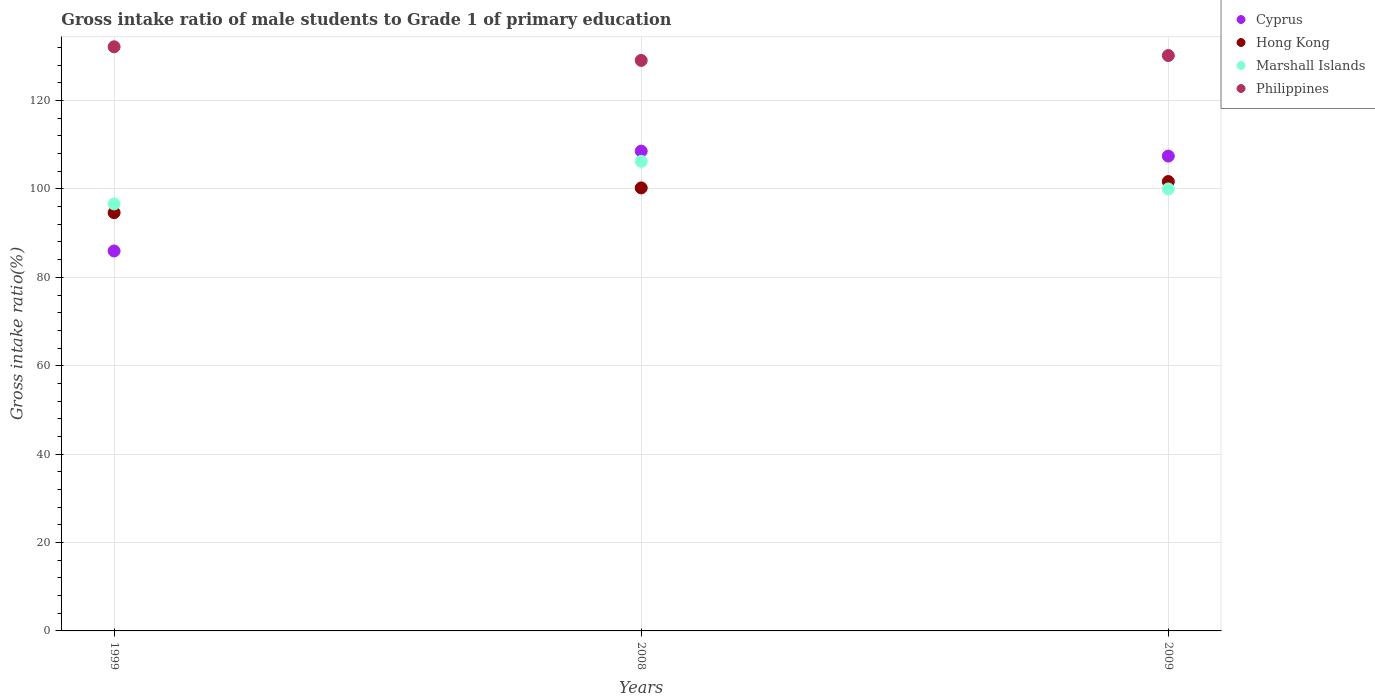How many different coloured dotlines are there?
Keep it short and to the point. 4. What is the gross intake ratio in Marshall Islands in 2009?
Offer a very short reply. 100. Across all years, what is the maximum gross intake ratio in Marshall Islands?
Provide a succinct answer. 106.25. Across all years, what is the minimum gross intake ratio in Cyprus?
Your answer should be compact. 85.97. In which year was the gross intake ratio in Hong Kong maximum?
Give a very brief answer. 2009. In which year was the gross intake ratio in Philippines minimum?
Ensure brevity in your answer.  2008. What is the total gross intake ratio in Philippines in the graph?
Offer a terse response. 391.44. What is the difference between the gross intake ratio in Philippines in 1999 and that in 2008?
Your response must be concise. 3.08. What is the difference between the gross intake ratio in Hong Kong in 1999 and the gross intake ratio in Philippines in 2008?
Your answer should be very brief. -34.45. What is the average gross intake ratio in Cyprus per year?
Give a very brief answer. 100.66. In the year 2009, what is the difference between the gross intake ratio in Hong Kong and gross intake ratio in Cyprus?
Ensure brevity in your answer.  -5.76. In how many years, is the gross intake ratio in Philippines greater than 36 %?
Ensure brevity in your answer.  3. What is the ratio of the gross intake ratio in Philippines in 1999 to that in 2008?
Make the answer very short. 1.02. Is the gross intake ratio in Philippines in 1999 less than that in 2008?
Give a very brief answer. No. What is the difference between the highest and the second highest gross intake ratio in Marshall Islands?
Keep it short and to the point. 6.25. What is the difference between the highest and the lowest gross intake ratio in Hong Kong?
Provide a succinct answer. 7.04. Is it the case that in every year, the sum of the gross intake ratio in Marshall Islands and gross intake ratio in Hong Kong  is greater than the sum of gross intake ratio in Philippines and gross intake ratio in Cyprus?
Your response must be concise. No. Does the gross intake ratio in Marshall Islands monotonically increase over the years?
Your answer should be very brief. No. Is the gross intake ratio in Marshall Islands strictly greater than the gross intake ratio in Hong Kong over the years?
Offer a very short reply. No. Is the gross intake ratio in Marshall Islands strictly less than the gross intake ratio in Hong Kong over the years?
Provide a succinct answer. No. What is the difference between two consecutive major ticks on the Y-axis?
Offer a terse response. 20. Does the graph contain any zero values?
Your answer should be compact. No. How many legend labels are there?
Provide a short and direct response. 4. What is the title of the graph?
Your response must be concise. Gross intake ratio of male students to Grade 1 of primary education. What is the label or title of the X-axis?
Your answer should be very brief. Years. What is the label or title of the Y-axis?
Keep it short and to the point. Gross intake ratio(%). What is the Gross intake ratio(%) of Cyprus in 1999?
Your response must be concise. 85.97. What is the Gross intake ratio(%) of Hong Kong in 1999?
Your response must be concise. 94.64. What is the Gross intake ratio(%) of Marshall Islands in 1999?
Offer a very short reply. 96.61. What is the Gross intake ratio(%) in Philippines in 1999?
Offer a very short reply. 132.17. What is the Gross intake ratio(%) of Cyprus in 2008?
Your answer should be compact. 108.57. What is the Gross intake ratio(%) of Hong Kong in 2008?
Your answer should be very brief. 100.24. What is the Gross intake ratio(%) in Marshall Islands in 2008?
Make the answer very short. 106.25. What is the Gross intake ratio(%) in Philippines in 2008?
Your answer should be very brief. 129.09. What is the Gross intake ratio(%) of Cyprus in 2009?
Your answer should be compact. 107.44. What is the Gross intake ratio(%) of Hong Kong in 2009?
Offer a terse response. 101.68. What is the Gross intake ratio(%) of Philippines in 2009?
Your response must be concise. 130.19. Across all years, what is the maximum Gross intake ratio(%) in Cyprus?
Your response must be concise. 108.57. Across all years, what is the maximum Gross intake ratio(%) in Hong Kong?
Provide a succinct answer. 101.68. Across all years, what is the maximum Gross intake ratio(%) of Marshall Islands?
Make the answer very short. 106.25. Across all years, what is the maximum Gross intake ratio(%) of Philippines?
Offer a very short reply. 132.17. Across all years, what is the minimum Gross intake ratio(%) in Cyprus?
Make the answer very short. 85.97. Across all years, what is the minimum Gross intake ratio(%) of Hong Kong?
Ensure brevity in your answer.  94.64. Across all years, what is the minimum Gross intake ratio(%) in Marshall Islands?
Your answer should be very brief. 96.61. Across all years, what is the minimum Gross intake ratio(%) of Philippines?
Make the answer very short. 129.09. What is the total Gross intake ratio(%) of Cyprus in the graph?
Your answer should be very brief. 301.97. What is the total Gross intake ratio(%) of Hong Kong in the graph?
Your answer should be compact. 296.55. What is the total Gross intake ratio(%) in Marshall Islands in the graph?
Give a very brief answer. 302.86. What is the total Gross intake ratio(%) of Philippines in the graph?
Offer a terse response. 391.44. What is the difference between the Gross intake ratio(%) in Cyprus in 1999 and that in 2008?
Make the answer very short. -22.6. What is the difference between the Gross intake ratio(%) in Hong Kong in 1999 and that in 2008?
Give a very brief answer. -5.6. What is the difference between the Gross intake ratio(%) in Marshall Islands in 1999 and that in 2008?
Give a very brief answer. -9.64. What is the difference between the Gross intake ratio(%) of Philippines in 1999 and that in 2008?
Your answer should be very brief. 3.08. What is the difference between the Gross intake ratio(%) of Cyprus in 1999 and that in 2009?
Offer a very short reply. -21.47. What is the difference between the Gross intake ratio(%) of Hong Kong in 1999 and that in 2009?
Your answer should be very brief. -7.04. What is the difference between the Gross intake ratio(%) in Marshall Islands in 1999 and that in 2009?
Keep it short and to the point. -3.39. What is the difference between the Gross intake ratio(%) of Philippines in 1999 and that in 2009?
Ensure brevity in your answer.  1.98. What is the difference between the Gross intake ratio(%) of Cyprus in 2008 and that in 2009?
Your answer should be very brief. 1.13. What is the difference between the Gross intake ratio(%) in Hong Kong in 2008 and that in 2009?
Your answer should be compact. -1.44. What is the difference between the Gross intake ratio(%) of Marshall Islands in 2008 and that in 2009?
Ensure brevity in your answer.  6.25. What is the difference between the Gross intake ratio(%) in Philippines in 2008 and that in 2009?
Make the answer very short. -1.1. What is the difference between the Gross intake ratio(%) of Cyprus in 1999 and the Gross intake ratio(%) of Hong Kong in 2008?
Give a very brief answer. -14.27. What is the difference between the Gross intake ratio(%) of Cyprus in 1999 and the Gross intake ratio(%) of Marshall Islands in 2008?
Give a very brief answer. -20.28. What is the difference between the Gross intake ratio(%) of Cyprus in 1999 and the Gross intake ratio(%) of Philippines in 2008?
Your answer should be very brief. -43.12. What is the difference between the Gross intake ratio(%) of Hong Kong in 1999 and the Gross intake ratio(%) of Marshall Islands in 2008?
Make the answer very short. -11.61. What is the difference between the Gross intake ratio(%) in Hong Kong in 1999 and the Gross intake ratio(%) in Philippines in 2008?
Give a very brief answer. -34.45. What is the difference between the Gross intake ratio(%) in Marshall Islands in 1999 and the Gross intake ratio(%) in Philippines in 2008?
Ensure brevity in your answer.  -32.48. What is the difference between the Gross intake ratio(%) in Cyprus in 1999 and the Gross intake ratio(%) in Hong Kong in 2009?
Offer a terse response. -15.71. What is the difference between the Gross intake ratio(%) of Cyprus in 1999 and the Gross intake ratio(%) of Marshall Islands in 2009?
Your answer should be compact. -14.03. What is the difference between the Gross intake ratio(%) in Cyprus in 1999 and the Gross intake ratio(%) in Philippines in 2009?
Provide a succinct answer. -44.22. What is the difference between the Gross intake ratio(%) of Hong Kong in 1999 and the Gross intake ratio(%) of Marshall Islands in 2009?
Offer a terse response. -5.36. What is the difference between the Gross intake ratio(%) in Hong Kong in 1999 and the Gross intake ratio(%) in Philippines in 2009?
Make the answer very short. -35.55. What is the difference between the Gross intake ratio(%) of Marshall Islands in 1999 and the Gross intake ratio(%) of Philippines in 2009?
Offer a terse response. -33.58. What is the difference between the Gross intake ratio(%) in Cyprus in 2008 and the Gross intake ratio(%) in Hong Kong in 2009?
Provide a short and direct response. 6.89. What is the difference between the Gross intake ratio(%) of Cyprus in 2008 and the Gross intake ratio(%) of Marshall Islands in 2009?
Offer a very short reply. 8.57. What is the difference between the Gross intake ratio(%) in Cyprus in 2008 and the Gross intake ratio(%) in Philippines in 2009?
Give a very brief answer. -21.62. What is the difference between the Gross intake ratio(%) of Hong Kong in 2008 and the Gross intake ratio(%) of Marshall Islands in 2009?
Ensure brevity in your answer.  0.24. What is the difference between the Gross intake ratio(%) of Hong Kong in 2008 and the Gross intake ratio(%) of Philippines in 2009?
Offer a very short reply. -29.95. What is the difference between the Gross intake ratio(%) in Marshall Islands in 2008 and the Gross intake ratio(%) in Philippines in 2009?
Offer a very short reply. -23.94. What is the average Gross intake ratio(%) of Cyprus per year?
Give a very brief answer. 100.66. What is the average Gross intake ratio(%) in Hong Kong per year?
Your answer should be very brief. 98.85. What is the average Gross intake ratio(%) of Marshall Islands per year?
Offer a terse response. 100.95. What is the average Gross intake ratio(%) of Philippines per year?
Keep it short and to the point. 130.48. In the year 1999, what is the difference between the Gross intake ratio(%) in Cyprus and Gross intake ratio(%) in Hong Kong?
Offer a very short reply. -8.67. In the year 1999, what is the difference between the Gross intake ratio(%) in Cyprus and Gross intake ratio(%) in Marshall Islands?
Ensure brevity in your answer.  -10.64. In the year 1999, what is the difference between the Gross intake ratio(%) in Cyprus and Gross intake ratio(%) in Philippines?
Make the answer very short. -46.2. In the year 1999, what is the difference between the Gross intake ratio(%) of Hong Kong and Gross intake ratio(%) of Marshall Islands?
Give a very brief answer. -1.97. In the year 1999, what is the difference between the Gross intake ratio(%) in Hong Kong and Gross intake ratio(%) in Philippines?
Offer a terse response. -37.53. In the year 1999, what is the difference between the Gross intake ratio(%) in Marshall Islands and Gross intake ratio(%) in Philippines?
Your answer should be compact. -35.56. In the year 2008, what is the difference between the Gross intake ratio(%) in Cyprus and Gross intake ratio(%) in Hong Kong?
Give a very brief answer. 8.33. In the year 2008, what is the difference between the Gross intake ratio(%) of Cyprus and Gross intake ratio(%) of Marshall Islands?
Make the answer very short. 2.32. In the year 2008, what is the difference between the Gross intake ratio(%) of Cyprus and Gross intake ratio(%) of Philippines?
Keep it short and to the point. -20.52. In the year 2008, what is the difference between the Gross intake ratio(%) in Hong Kong and Gross intake ratio(%) in Marshall Islands?
Your answer should be very brief. -6.01. In the year 2008, what is the difference between the Gross intake ratio(%) in Hong Kong and Gross intake ratio(%) in Philippines?
Provide a succinct answer. -28.85. In the year 2008, what is the difference between the Gross intake ratio(%) of Marshall Islands and Gross intake ratio(%) of Philippines?
Offer a terse response. -22.84. In the year 2009, what is the difference between the Gross intake ratio(%) in Cyprus and Gross intake ratio(%) in Hong Kong?
Make the answer very short. 5.76. In the year 2009, what is the difference between the Gross intake ratio(%) in Cyprus and Gross intake ratio(%) in Marshall Islands?
Make the answer very short. 7.44. In the year 2009, what is the difference between the Gross intake ratio(%) of Cyprus and Gross intake ratio(%) of Philippines?
Your response must be concise. -22.75. In the year 2009, what is the difference between the Gross intake ratio(%) of Hong Kong and Gross intake ratio(%) of Marshall Islands?
Your answer should be compact. 1.68. In the year 2009, what is the difference between the Gross intake ratio(%) in Hong Kong and Gross intake ratio(%) in Philippines?
Your response must be concise. -28.51. In the year 2009, what is the difference between the Gross intake ratio(%) in Marshall Islands and Gross intake ratio(%) in Philippines?
Give a very brief answer. -30.19. What is the ratio of the Gross intake ratio(%) in Cyprus in 1999 to that in 2008?
Make the answer very short. 0.79. What is the ratio of the Gross intake ratio(%) of Hong Kong in 1999 to that in 2008?
Offer a very short reply. 0.94. What is the ratio of the Gross intake ratio(%) in Marshall Islands in 1999 to that in 2008?
Provide a short and direct response. 0.91. What is the ratio of the Gross intake ratio(%) of Philippines in 1999 to that in 2008?
Your response must be concise. 1.02. What is the ratio of the Gross intake ratio(%) in Cyprus in 1999 to that in 2009?
Your answer should be compact. 0.8. What is the ratio of the Gross intake ratio(%) of Hong Kong in 1999 to that in 2009?
Provide a short and direct response. 0.93. What is the ratio of the Gross intake ratio(%) in Marshall Islands in 1999 to that in 2009?
Offer a very short reply. 0.97. What is the ratio of the Gross intake ratio(%) of Philippines in 1999 to that in 2009?
Offer a very short reply. 1.02. What is the ratio of the Gross intake ratio(%) of Cyprus in 2008 to that in 2009?
Give a very brief answer. 1.01. What is the ratio of the Gross intake ratio(%) in Hong Kong in 2008 to that in 2009?
Make the answer very short. 0.99. What is the ratio of the Gross intake ratio(%) of Marshall Islands in 2008 to that in 2009?
Keep it short and to the point. 1.06. What is the ratio of the Gross intake ratio(%) in Philippines in 2008 to that in 2009?
Keep it short and to the point. 0.99. What is the difference between the highest and the second highest Gross intake ratio(%) of Cyprus?
Offer a terse response. 1.13. What is the difference between the highest and the second highest Gross intake ratio(%) of Hong Kong?
Make the answer very short. 1.44. What is the difference between the highest and the second highest Gross intake ratio(%) of Marshall Islands?
Provide a short and direct response. 6.25. What is the difference between the highest and the second highest Gross intake ratio(%) in Philippines?
Your response must be concise. 1.98. What is the difference between the highest and the lowest Gross intake ratio(%) in Cyprus?
Your response must be concise. 22.6. What is the difference between the highest and the lowest Gross intake ratio(%) of Hong Kong?
Your response must be concise. 7.04. What is the difference between the highest and the lowest Gross intake ratio(%) of Marshall Islands?
Your answer should be very brief. 9.64. What is the difference between the highest and the lowest Gross intake ratio(%) of Philippines?
Your answer should be very brief. 3.08. 